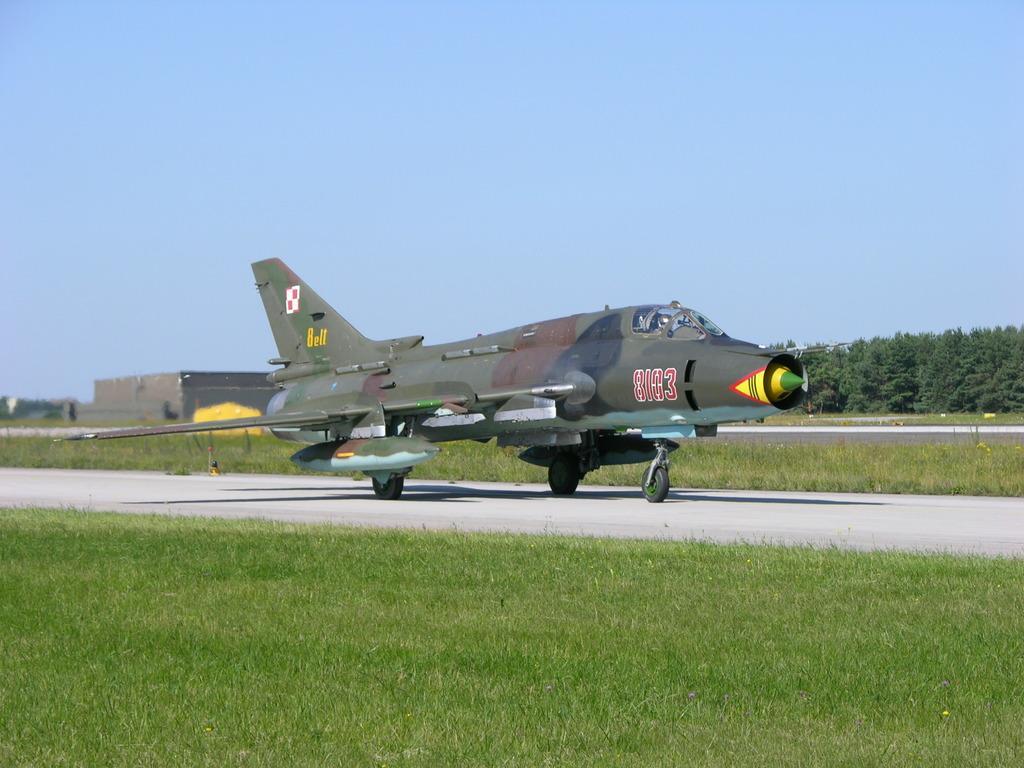Describe this image in one or two sentences. In the middle of this image, there is a gray color aircraft on a runway. On both sides of this runway, there's grass on the ground. In the background, there are trees, buildings and grass on the ground and there is blue sky. 